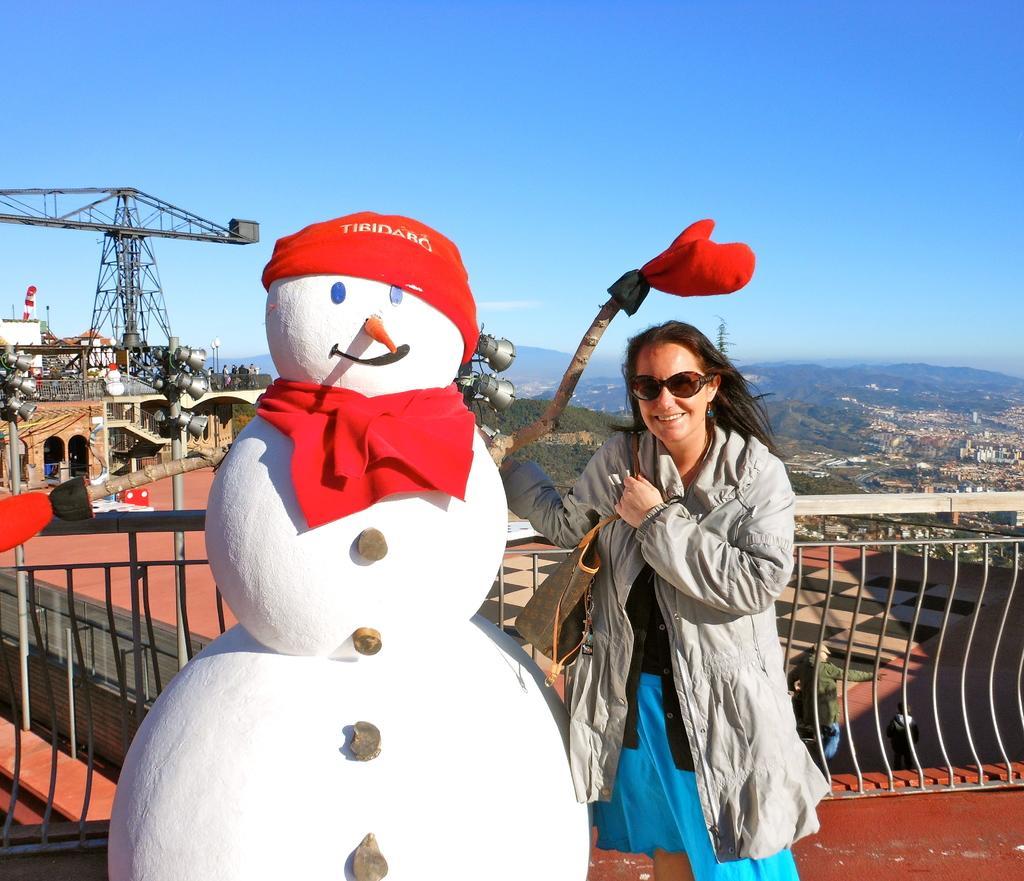Describe this image in one or two sentences. Here I can see a woman is standing beside the snowman, smiling and and giving pose for the picture. She is wearing a jacket and holding a bag. At the back of her I can see the railing. In the background there are some buildings, poles and trees. On the top of the image I can see the sky. 